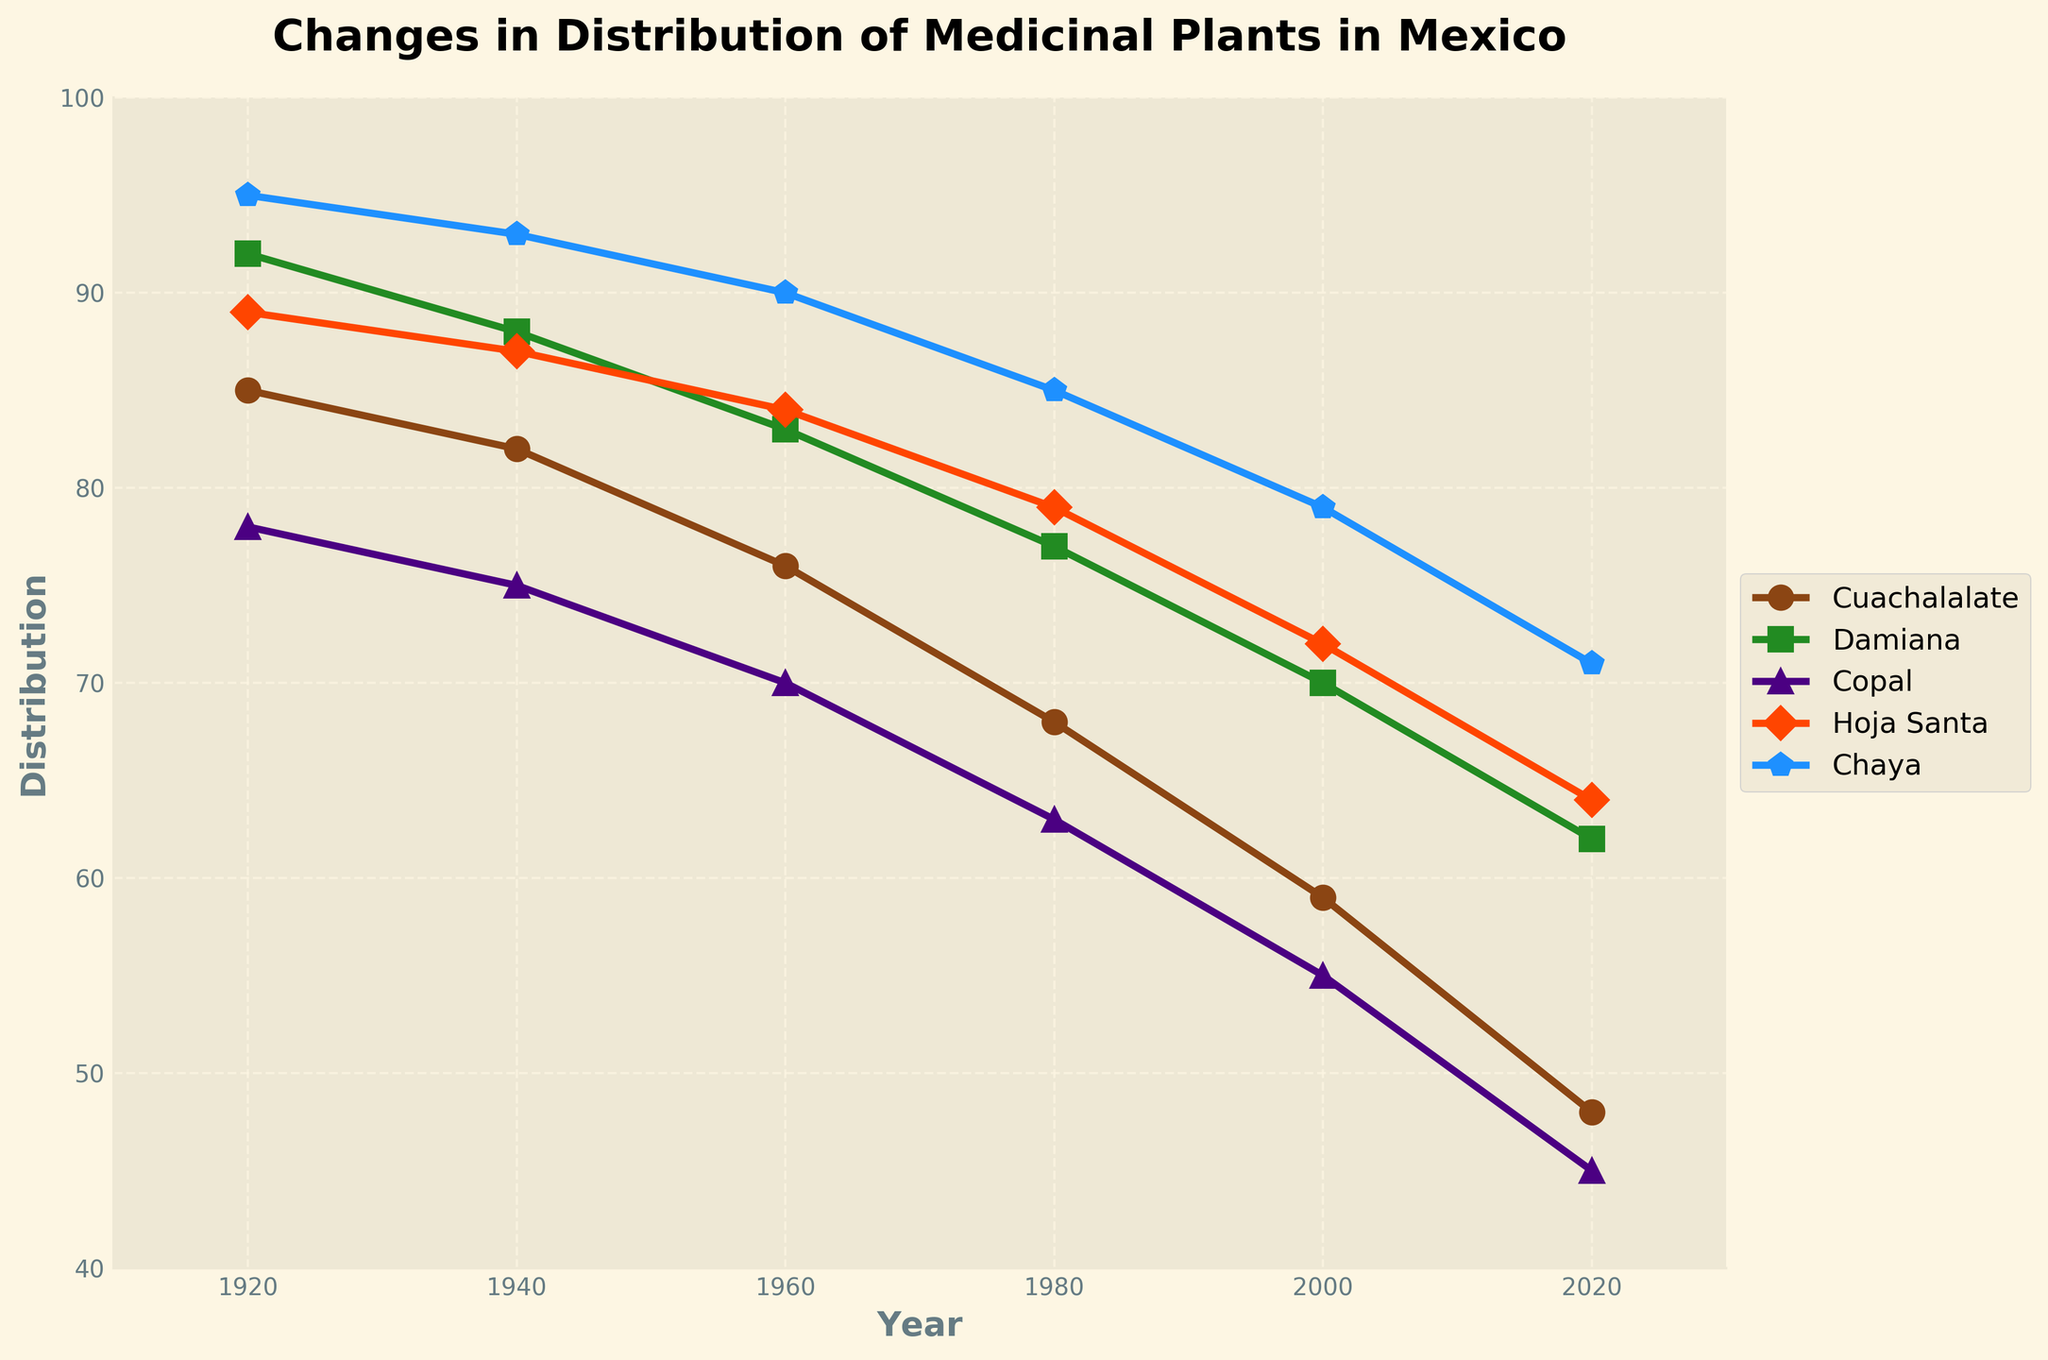What is the overall trend in the distribution of Cuachalalate from 1920 to 2020? The plot shows a gradual decline in Cuachalalate distribution across the years from 1920 to 2020.
Answer: Decline Between which two years was the largest decrease in the distribution of Hoja Santa observed? By examining the trend lines for Hoja Santa, the largest drop in percentage seems to occur between 1980 and 2000.
Answer: 1980 and 2000 Which medicinal plant had the highest distribution in 2020? By looking at the end points on the plot for the year 2020, Chaya had the highest distribution among the medicinal plants listed.
Answer: Chaya What is the difference in distribution between Damiana and Cuachalalate in 1940? From the plot, the distribution values for Damiana and Cuachalalate in 1940 are 88 and 82 respectively. The difference is 88 - 82 = 6.
Answer: 6 Which plant shows the steepest decline in distribution over the entire period from 1920 to 2020? By observing the slopes of the decline for all the plants, Cuachalalate shows the steepest decline, going from 85 to 48.
Answer: Cuachalalate In which decade did Copal and Damiana have the smallest difference in their distribution? Observing the plotted lines, the smallest difference between Copal and Damiana appears during the 1960s when Copal is at 70 and Damiana is at 83, giving a difference of 13.
Answer: 1960s What is the average distribution of Chaya from 1920 to 2020? The values for Chaya distribution over the years 1920, 1940, 1960, 1980, 2000, and 2020 are 95, 93, 90, 85, 79, and 71 respectively. The average is calculated as (95 + 93 + 90 + 85 + 79 + 71) / 6 = 85.5.
Answer: 85.5 By how much did the distribution of Hoja Santa change from 2000 to 2020? Hoja Santa’s distribution in 2000 is 72 and in 2020 it’s 64. The change is 72 - 64 = 8.
Answer: 8 Is there any year where the distribution of Cuachalalate and Chaya are equal? Examining the lines, Cuachalalate and Chaya's distributions do not intersect at any point across the years displayed.
Answer: No Which plant shows the most consistent decline over the century? The plant that shows a steady, consistent slope in the trend line without abrupt changes is Damiana.
Answer: Damiana 